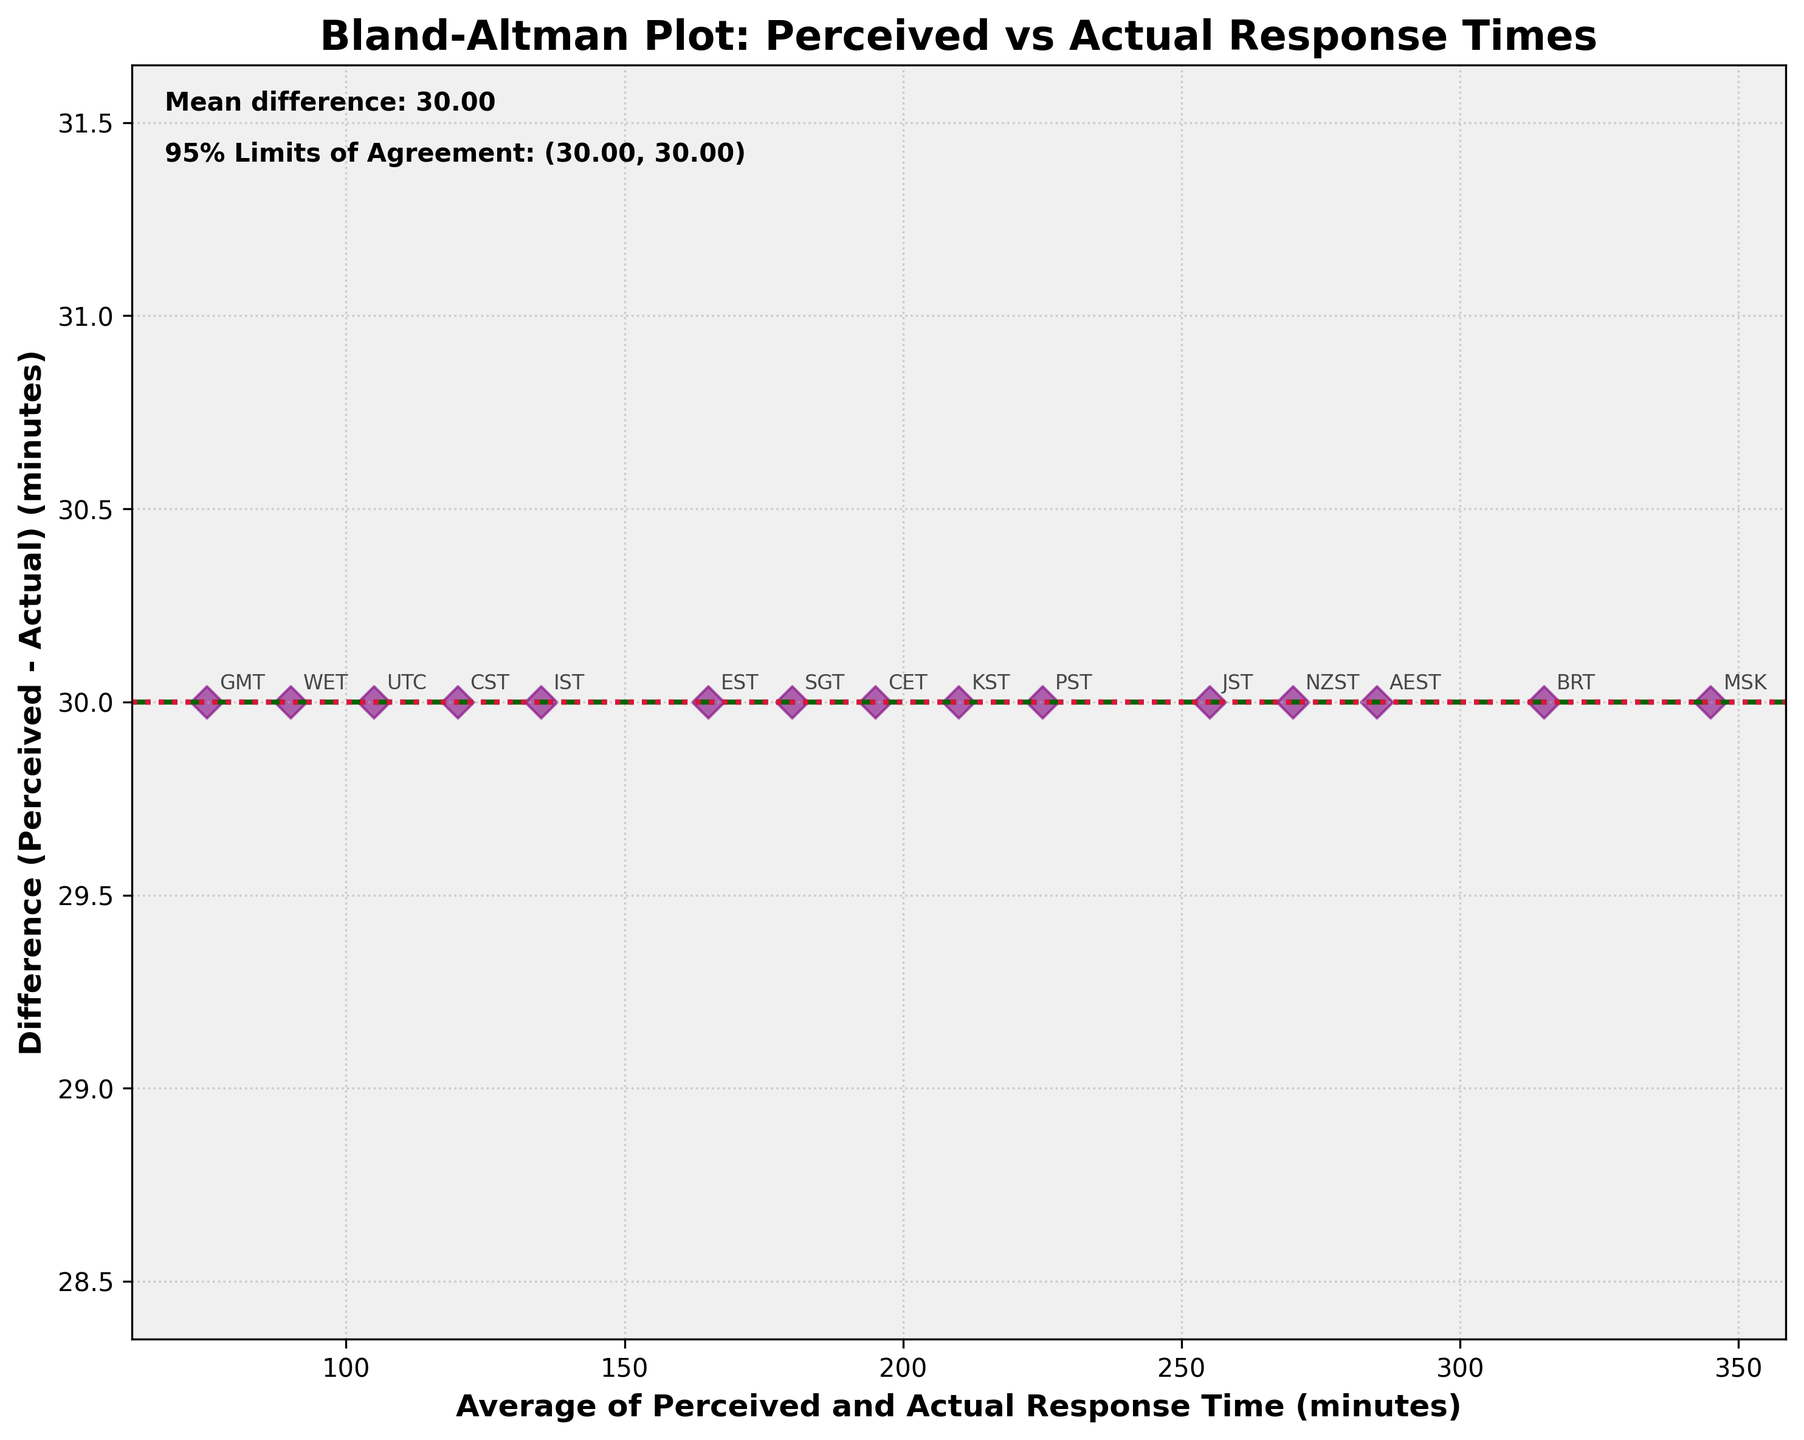What's the title of the plot? The title is located at the top of the figure, providing a clear description of what the plot represents.
Answer: Bland-Altman Plot: Perceived vs Actual Response Times What are the limits of agreement in the plot? The limits of agreement are displayed as two horizontal dashed lines, with an annotated description included in the plot. These represent the range within which most differences between perceived and actual response times fall.
Answer: (-1.55, 181.55) How many data points are plotted? Count the number of distinct markers on the plot, each representing a different timezone.
Answer: 15 What does the point marked 'PST' represent in the plot? Look for the label 'PST' annotated next to its corresponding point. This point indicates the average perceived and actual response time along the x-axis and the difference on the y-axis.
Answer: Average: 225, Difference: 30 What is the significance of the dark green dashed line in the plot? The dark green dashed line represents the mean difference between perceived and actual response times. Check the text annotation or the position along the y-axis.
Answer: Mean difference: 90 Which timezone has the greatest positive difference? Identify the highest point on the plot along the y-axis. The annotation next to this point will indicate the associated timezone.
Answer: MSK Which timezone has the smallest difference? Identify the point closest to the x-axis. The annotation next to this point will indicate the associated timezone.
Answer: UTC What's the average perceived and actual response time for 'UTC' timezone? Find the point labeled 'UTC'; the x-coordinate indicates the average of perceived and actual response times. The point's x-coordinate needs to be examined.
Answer: Average: 105 Among 'EST' and 'GMT', which timezone has a higher perceived response time? Compare the perceived response times of 'EST' and 'GMT' along the y-axis.
Answer: EST Is there any timezone for which the perceived response time is exactly 300 minutes? Identify if any point on the y-axis is exactly at the 300-minute mark. Check the corresponding annotation.
Answer: BRT 